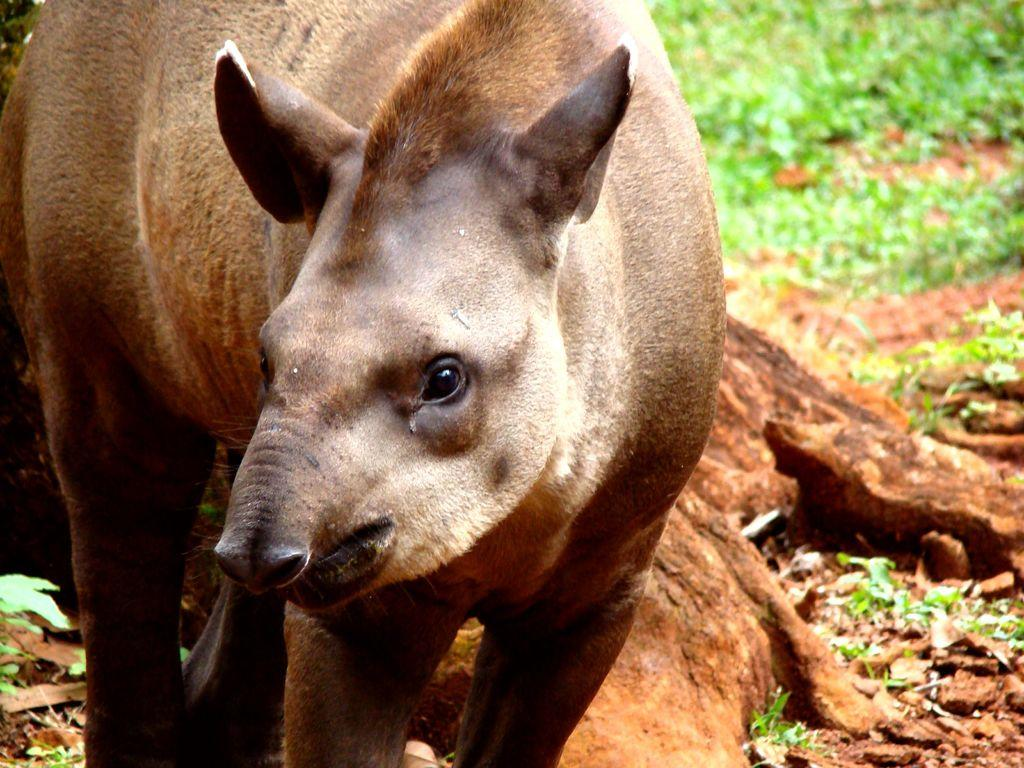What type of animal is in the foreground of the image? The type of animal cannot be determined from the provided facts. What can be seen in the background of the image? There is grass in the background of the image. What is located in the center of the image? There is a rock and mud in the center of the image. What type of jewel is hanging from the animal's throat in the image? There is no animal or jewel present in the image. Can you provide an example of a similar image with an animal and a jewel? Since there is no animal or jewel present in the image, it is not possible to provide an example of a similar image. 